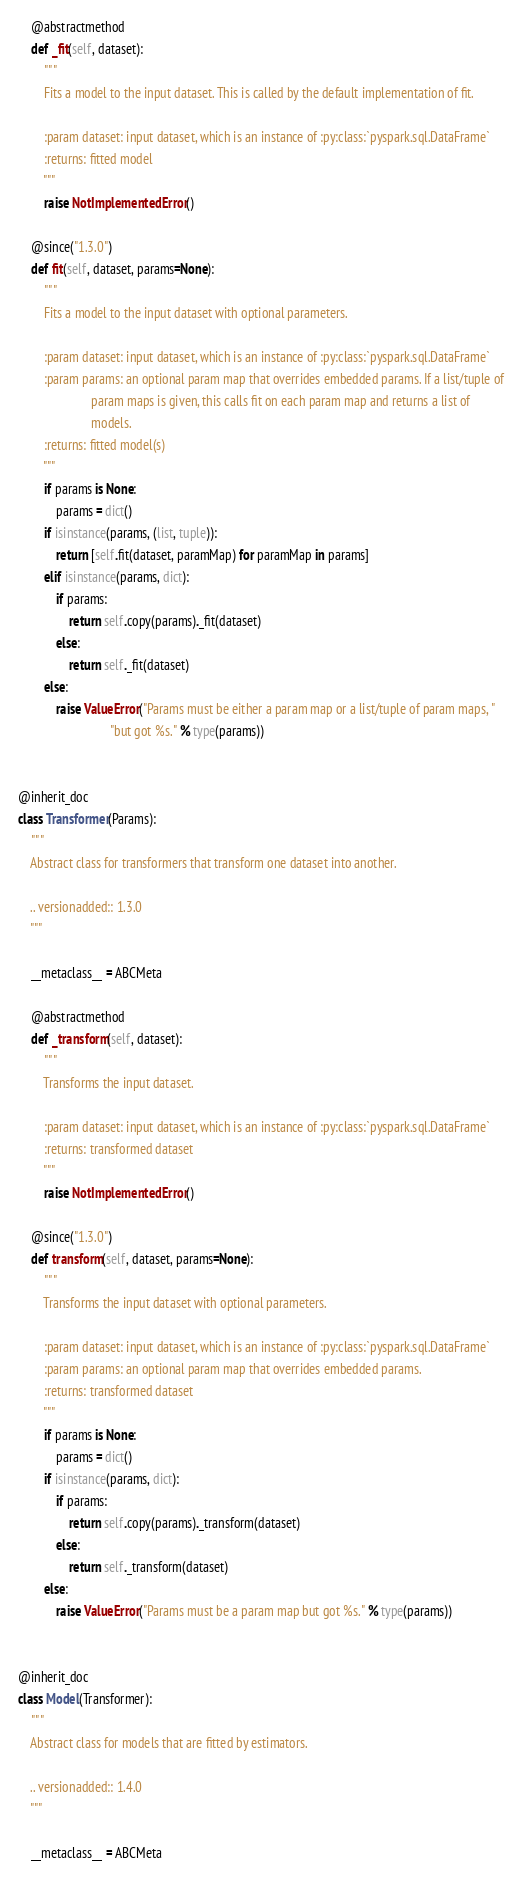<code> <loc_0><loc_0><loc_500><loc_500><_Python_>
    @abstractmethod
    def _fit(self, dataset):
        """
        Fits a model to the input dataset. This is called by the default implementation of fit.

        :param dataset: input dataset, which is an instance of :py:class:`pyspark.sql.DataFrame`
        :returns: fitted model
        """
        raise NotImplementedError()

    @since("1.3.0")
    def fit(self, dataset, params=None):
        """
        Fits a model to the input dataset with optional parameters.

        :param dataset: input dataset, which is an instance of :py:class:`pyspark.sql.DataFrame`
        :param params: an optional param map that overrides embedded params. If a list/tuple of
                       param maps is given, this calls fit on each param map and returns a list of
                       models.
        :returns: fitted model(s)
        """
        if params is None:
            params = dict()
        if isinstance(params, (list, tuple)):
            return [self.fit(dataset, paramMap) for paramMap in params]
        elif isinstance(params, dict):
            if params:
                return self.copy(params)._fit(dataset)
            else:
                return self._fit(dataset)
        else:
            raise ValueError("Params must be either a param map or a list/tuple of param maps, "
                             "but got %s." % type(params))


@inherit_doc
class Transformer(Params):
    """
    Abstract class for transformers that transform one dataset into another.

    .. versionadded:: 1.3.0
    """

    __metaclass__ = ABCMeta

    @abstractmethod
    def _transform(self, dataset):
        """
        Transforms the input dataset.

        :param dataset: input dataset, which is an instance of :py:class:`pyspark.sql.DataFrame`
        :returns: transformed dataset
        """
        raise NotImplementedError()

    @since("1.3.0")
    def transform(self, dataset, params=None):
        """
        Transforms the input dataset with optional parameters.

        :param dataset: input dataset, which is an instance of :py:class:`pyspark.sql.DataFrame`
        :param params: an optional param map that overrides embedded params.
        :returns: transformed dataset
        """
        if params is None:
            params = dict()
        if isinstance(params, dict):
            if params:
                return self.copy(params)._transform(dataset)
            else:
                return self._transform(dataset)
        else:
            raise ValueError("Params must be a param map but got %s." % type(params))


@inherit_doc
class Model(Transformer):
    """
    Abstract class for models that are fitted by estimators.

    .. versionadded:: 1.4.0
    """

    __metaclass__ = ABCMeta
</code> 